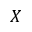<formula> <loc_0><loc_0><loc_500><loc_500>X</formula> 